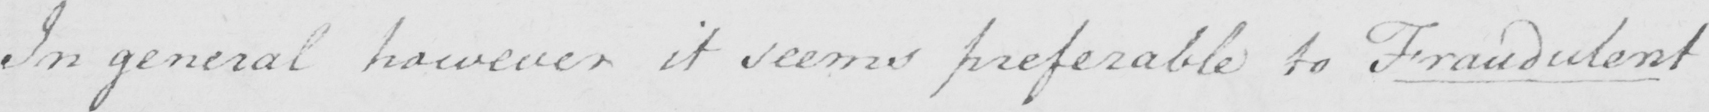What does this handwritten line say? In general however it seems preferable to Fraudulent 